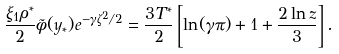<formula> <loc_0><loc_0><loc_500><loc_500>\frac { \xi _ { 1 } \rho ^ { * } } { 2 } \tilde { \phi } ( y _ { * } ) e ^ { - \gamma \zeta ^ { 2 } / 2 } = \frac { 3 T ^ { * } } { 2 } \left [ \ln ( \gamma \pi ) + 1 + \frac { 2 \ln z } { 3 } \right ] .</formula> 